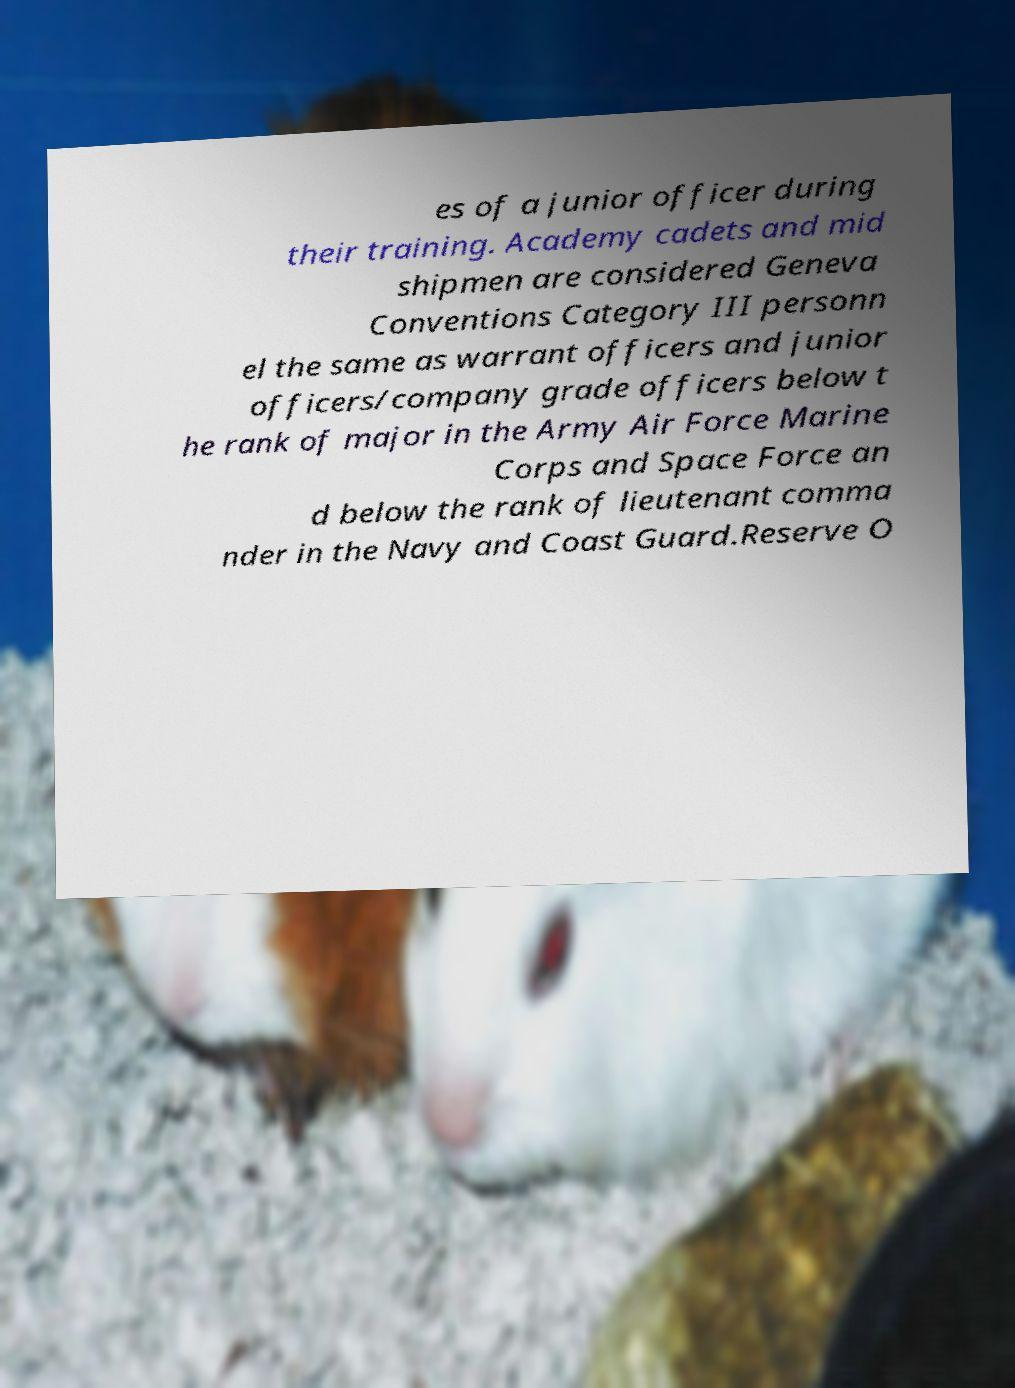Could you assist in decoding the text presented in this image and type it out clearly? es of a junior officer during their training. Academy cadets and mid shipmen are considered Geneva Conventions Category III personn el the same as warrant officers and junior officers/company grade officers below t he rank of major in the Army Air Force Marine Corps and Space Force an d below the rank of lieutenant comma nder in the Navy and Coast Guard.Reserve O 